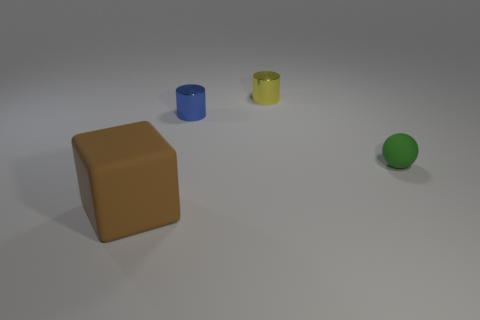Add 4 big yellow matte cubes. How many objects exist? 8 Subtract all cubes. How many objects are left? 3 Subtract 0 cyan cubes. How many objects are left? 4 Subtract all tiny blue metal objects. Subtract all tiny green matte things. How many objects are left? 2 Add 1 blue metallic objects. How many blue metallic objects are left? 2 Add 3 tiny blue cylinders. How many tiny blue cylinders exist? 4 